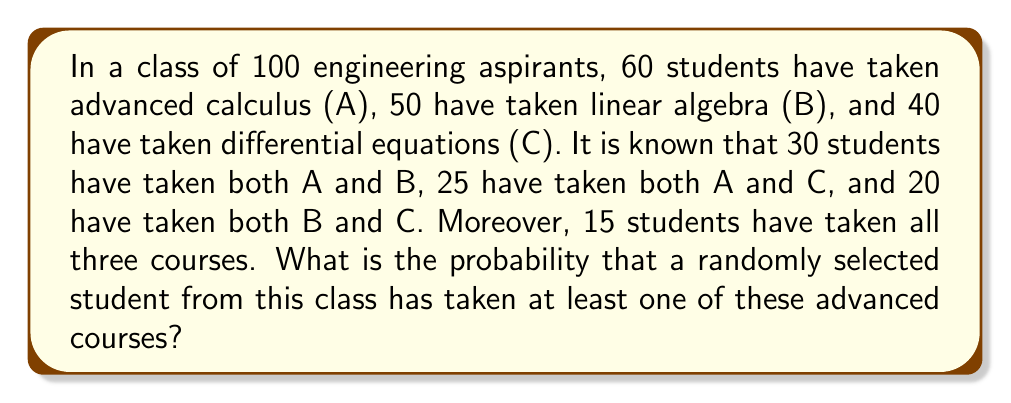Give your solution to this math problem. Let's approach this problem step-by-step using the principle of inclusion-exclusion:

1) First, let's define our universe: $n(U) = 100$ (total number of students)

2) We need to find $n(A \cup B \cup C)$, the number of students who have taken at least one of the courses.

3) The principle of inclusion-exclusion states:

   $$n(A \cup B \cup C) = n(A) + n(B) + n(C) - n(A \cap B) - n(A \cap C) - n(B \cap C) + n(A \cap B \cap C)$$

4) We are given:
   $n(A) = 60$, $n(B) = 50$, $n(C) = 40$
   $n(A \cap B) = 30$, $n(A \cap C) = 25$, $n(B \cap C) = 20$
   $n(A \cap B \cap C) = 15$

5) Substituting these values:

   $$n(A \cup B \cup C) = 60 + 50 + 40 - 30 - 25 - 20 + 15 = 90$$

6) Therefore, 90 students have taken at least one of these advanced courses.

7) The probability is then:

   $$P(\text{at least one course}) = \frac{n(A \cup B \cup C)}{n(U)} = \frac{90}{100} = 0.90$$
Answer: $0.90$ or $90\%$ 